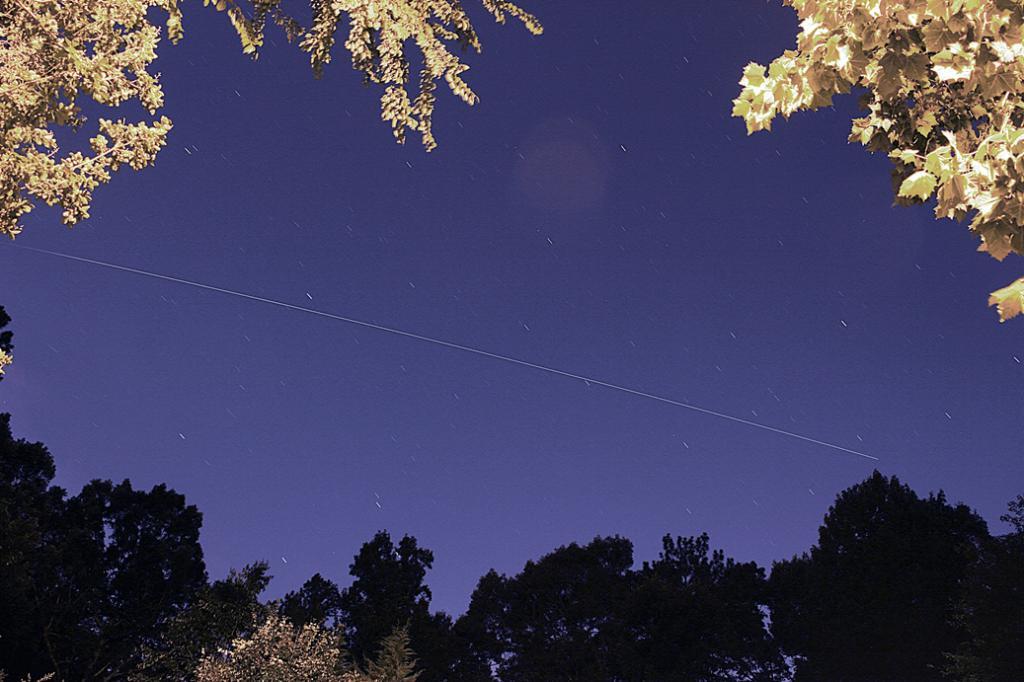In one or two sentences, can you explain what this image depicts? This picture describe about the night view of the sky. In front there is a shooting star in the sky. In the front bottom side of the image there are some trees. 